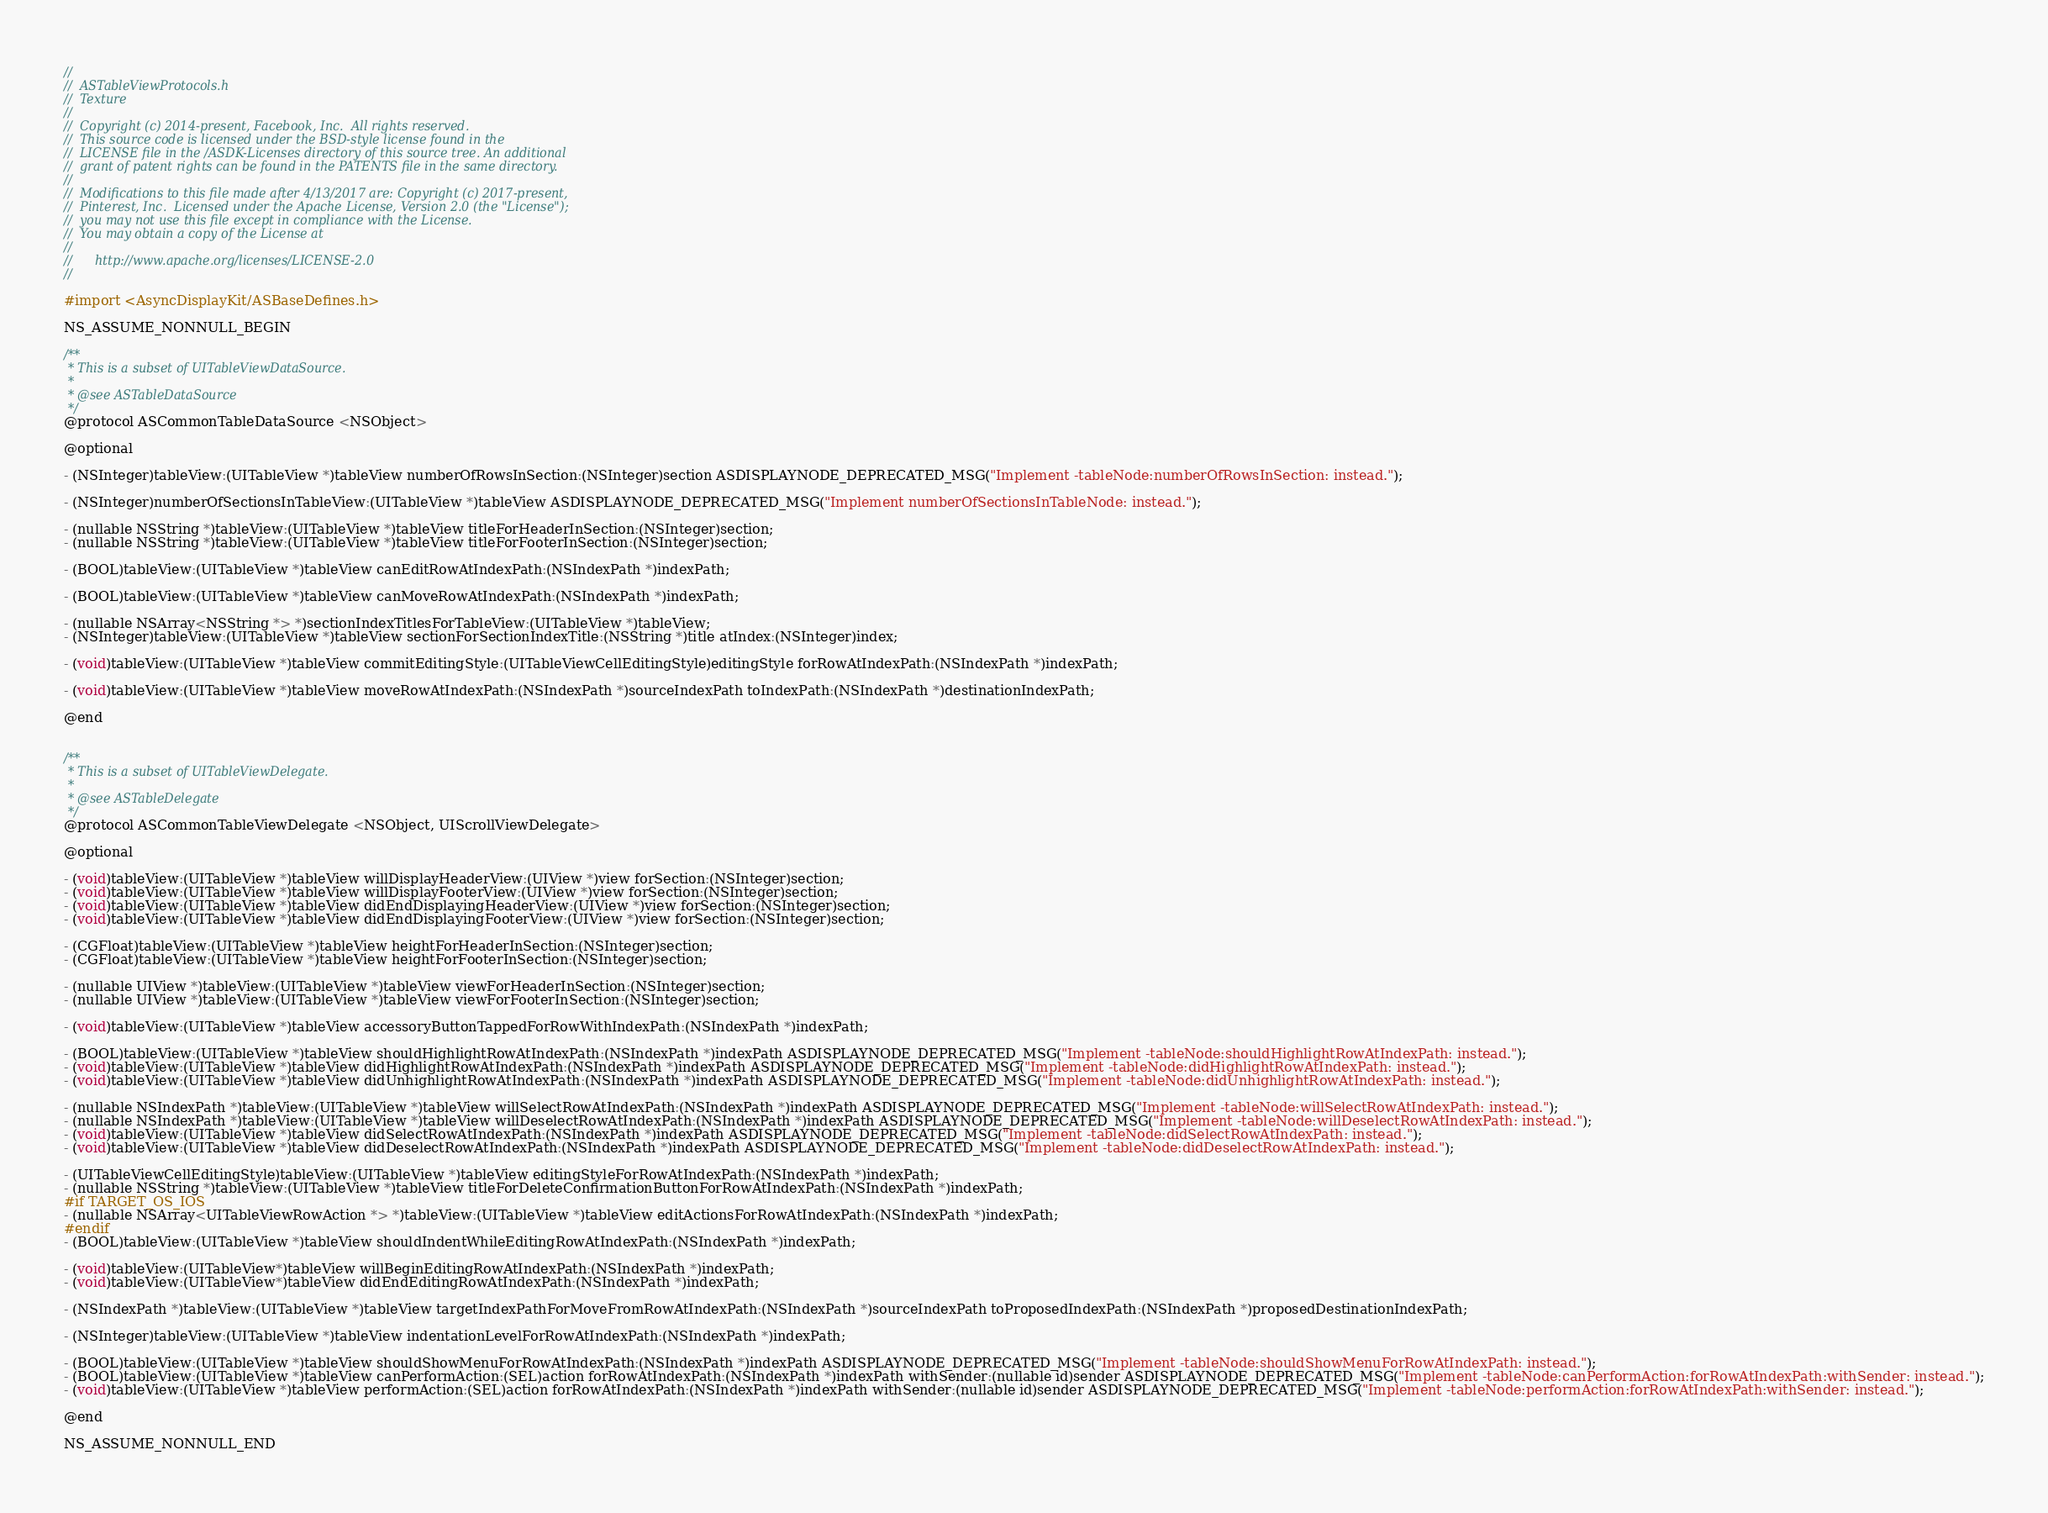<code> <loc_0><loc_0><loc_500><loc_500><_C_>//
//  ASTableViewProtocols.h
//  Texture
//
//  Copyright (c) 2014-present, Facebook, Inc.  All rights reserved.
//  This source code is licensed under the BSD-style license found in the
//  LICENSE file in the /ASDK-Licenses directory of this source tree. An additional
//  grant of patent rights can be found in the PATENTS file in the same directory.
//
//  Modifications to this file made after 4/13/2017 are: Copyright (c) 2017-present,
//  Pinterest, Inc.  Licensed under the Apache License, Version 2.0 (the "License");
//  you may not use this file except in compliance with the License.
//  You may obtain a copy of the License at
//
//      http://www.apache.org/licenses/LICENSE-2.0
//

#import <AsyncDisplayKit/ASBaseDefines.h>

NS_ASSUME_NONNULL_BEGIN

/**
 * This is a subset of UITableViewDataSource.
 *
 * @see ASTableDataSource
 */
@protocol ASCommonTableDataSource <NSObject>

@optional

- (NSInteger)tableView:(UITableView *)tableView numberOfRowsInSection:(NSInteger)section ASDISPLAYNODE_DEPRECATED_MSG("Implement -tableNode:numberOfRowsInSection: instead.");

- (NSInteger)numberOfSectionsInTableView:(UITableView *)tableView ASDISPLAYNODE_DEPRECATED_MSG("Implement numberOfSectionsInTableNode: instead.");

- (nullable NSString *)tableView:(UITableView *)tableView titleForHeaderInSection:(NSInteger)section;
- (nullable NSString *)tableView:(UITableView *)tableView titleForFooterInSection:(NSInteger)section;

- (BOOL)tableView:(UITableView *)tableView canEditRowAtIndexPath:(NSIndexPath *)indexPath;

- (BOOL)tableView:(UITableView *)tableView canMoveRowAtIndexPath:(NSIndexPath *)indexPath;

- (nullable NSArray<NSString *> *)sectionIndexTitlesForTableView:(UITableView *)tableView;
- (NSInteger)tableView:(UITableView *)tableView sectionForSectionIndexTitle:(NSString *)title atIndex:(NSInteger)index;

- (void)tableView:(UITableView *)tableView commitEditingStyle:(UITableViewCellEditingStyle)editingStyle forRowAtIndexPath:(NSIndexPath *)indexPath;

- (void)tableView:(UITableView *)tableView moveRowAtIndexPath:(NSIndexPath *)sourceIndexPath toIndexPath:(NSIndexPath *)destinationIndexPath;

@end


/**
 * This is a subset of UITableViewDelegate.
 *
 * @see ASTableDelegate
 */
@protocol ASCommonTableViewDelegate <NSObject, UIScrollViewDelegate>

@optional

- (void)tableView:(UITableView *)tableView willDisplayHeaderView:(UIView *)view forSection:(NSInteger)section;
- (void)tableView:(UITableView *)tableView willDisplayFooterView:(UIView *)view forSection:(NSInteger)section;
- (void)tableView:(UITableView *)tableView didEndDisplayingHeaderView:(UIView *)view forSection:(NSInteger)section;
- (void)tableView:(UITableView *)tableView didEndDisplayingFooterView:(UIView *)view forSection:(NSInteger)section;

- (CGFloat)tableView:(UITableView *)tableView heightForHeaderInSection:(NSInteger)section;
- (CGFloat)tableView:(UITableView *)tableView heightForFooterInSection:(NSInteger)section;

- (nullable UIView *)tableView:(UITableView *)tableView viewForHeaderInSection:(NSInteger)section;
- (nullable UIView *)tableView:(UITableView *)tableView viewForFooterInSection:(NSInteger)section;

- (void)tableView:(UITableView *)tableView accessoryButtonTappedForRowWithIndexPath:(NSIndexPath *)indexPath;

- (BOOL)tableView:(UITableView *)tableView shouldHighlightRowAtIndexPath:(NSIndexPath *)indexPath ASDISPLAYNODE_DEPRECATED_MSG("Implement -tableNode:shouldHighlightRowAtIndexPath: instead.");
- (void)tableView:(UITableView *)tableView didHighlightRowAtIndexPath:(NSIndexPath *)indexPath ASDISPLAYNODE_DEPRECATED_MSG("Implement -tableNode:didHighlightRowAtIndexPath: instead.");
- (void)tableView:(UITableView *)tableView didUnhighlightRowAtIndexPath:(NSIndexPath *)indexPath ASDISPLAYNODE_DEPRECATED_MSG("Implement -tableNode:didUnhighlightRowAtIndexPath: instead.");

- (nullable NSIndexPath *)tableView:(UITableView *)tableView willSelectRowAtIndexPath:(NSIndexPath *)indexPath ASDISPLAYNODE_DEPRECATED_MSG("Implement -tableNode:willSelectRowAtIndexPath: instead.");
- (nullable NSIndexPath *)tableView:(UITableView *)tableView willDeselectRowAtIndexPath:(NSIndexPath *)indexPath ASDISPLAYNODE_DEPRECATED_MSG("Implement -tableNode:willDeselectRowAtIndexPath: instead.");
- (void)tableView:(UITableView *)tableView didSelectRowAtIndexPath:(NSIndexPath *)indexPath ASDISPLAYNODE_DEPRECATED_MSG("Implement -tableNode:didSelectRowAtIndexPath: instead.");
- (void)tableView:(UITableView *)tableView didDeselectRowAtIndexPath:(NSIndexPath *)indexPath ASDISPLAYNODE_DEPRECATED_MSG("Implement -tableNode:didDeselectRowAtIndexPath: instead.");

- (UITableViewCellEditingStyle)tableView:(UITableView *)tableView editingStyleForRowAtIndexPath:(NSIndexPath *)indexPath;
- (nullable NSString *)tableView:(UITableView *)tableView titleForDeleteConfirmationButtonForRowAtIndexPath:(NSIndexPath *)indexPath;
#if TARGET_OS_IOS
- (nullable NSArray<UITableViewRowAction *> *)tableView:(UITableView *)tableView editActionsForRowAtIndexPath:(NSIndexPath *)indexPath;
#endif
- (BOOL)tableView:(UITableView *)tableView shouldIndentWhileEditingRowAtIndexPath:(NSIndexPath *)indexPath;

- (void)tableView:(UITableView*)tableView willBeginEditingRowAtIndexPath:(NSIndexPath *)indexPath;
- (void)tableView:(UITableView*)tableView didEndEditingRowAtIndexPath:(NSIndexPath *)indexPath;

- (NSIndexPath *)tableView:(UITableView *)tableView targetIndexPathForMoveFromRowAtIndexPath:(NSIndexPath *)sourceIndexPath toProposedIndexPath:(NSIndexPath *)proposedDestinationIndexPath;

- (NSInteger)tableView:(UITableView *)tableView indentationLevelForRowAtIndexPath:(NSIndexPath *)indexPath;

- (BOOL)tableView:(UITableView *)tableView shouldShowMenuForRowAtIndexPath:(NSIndexPath *)indexPath ASDISPLAYNODE_DEPRECATED_MSG("Implement -tableNode:shouldShowMenuForRowAtIndexPath: instead.");
- (BOOL)tableView:(UITableView *)tableView canPerformAction:(SEL)action forRowAtIndexPath:(NSIndexPath *)indexPath withSender:(nullable id)sender ASDISPLAYNODE_DEPRECATED_MSG("Implement -tableNode:canPerformAction:forRowAtIndexPath:withSender: instead.");
- (void)tableView:(UITableView *)tableView performAction:(SEL)action forRowAtIndexPath:(NSIndexPath *)indexPath withSender:(nullable id)sender ASDISPLAYNODE_DEPRECATED_MSG("Implement -tableNode:performAction:forRowAtIndexPath:withSender: instead.");

@end

NS_ASSUME_NONNULL_END
</code> 